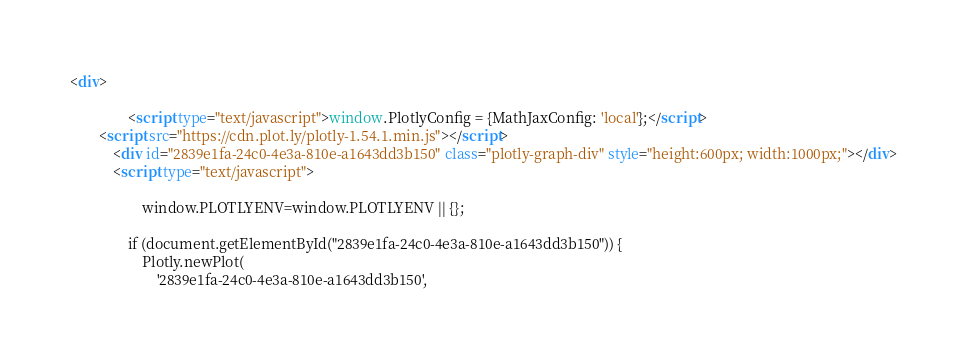Convert code to text. <code><loc_0><loc_0><loc_500><loc_500><_HTML_><div>
        
                <script type="text/javascript">window.PlotlyConfig = {MathJaxConfig: 'local'};</script>
        <script src="https://cdn.plot.ly/plotly-1.54.1.min.js"></script>    
            <div id="2839e1fa-24c0-4e3a-810e-a1643dd3b150" class="plotly-graph-div" style="height:600px; width:1000px;"></div>
            <script type="text/javascript">
                
                    window.PLOTLYENV=window.PLOTLYENV || {};
                    
                if (document.getElementById("2839e1fa-24c0-4e3a-810e-a1643dd3b150")) {
                    Plotly.newPlot(
                        '2839e1fa-24c0-4e3a-810e-a1643dd3b150',</code> 